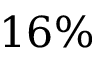<formula> <loc_0><loc_0><loc_500><loc_500>1 6 \%</formula> 